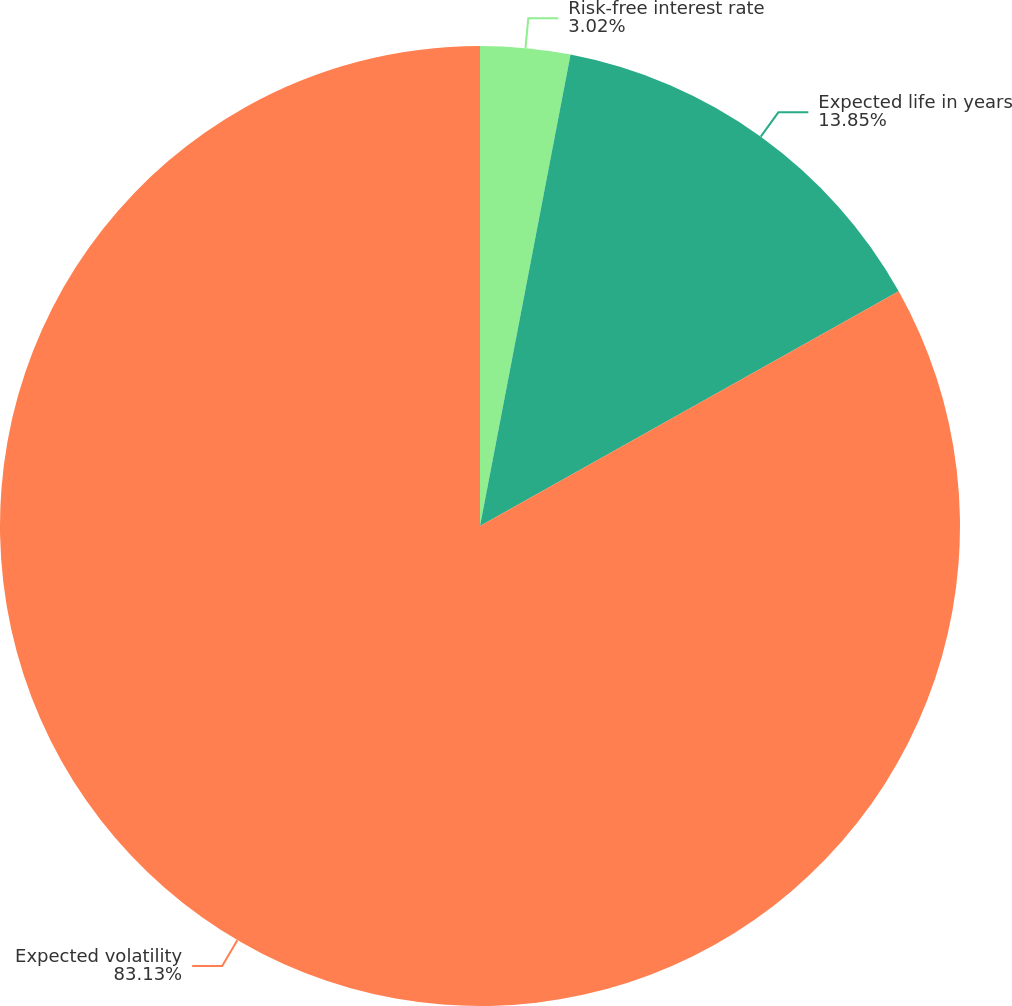<chart> <loc_0><loc_0><loc_500><loc_500><pie_chart><fcel>Risk-free interest rate<fcel>Expected life in years<fcel>Expected volatility<nl><fcel>3.02%<fcel>13.85%<fcel>83.13%<nl></chart> 